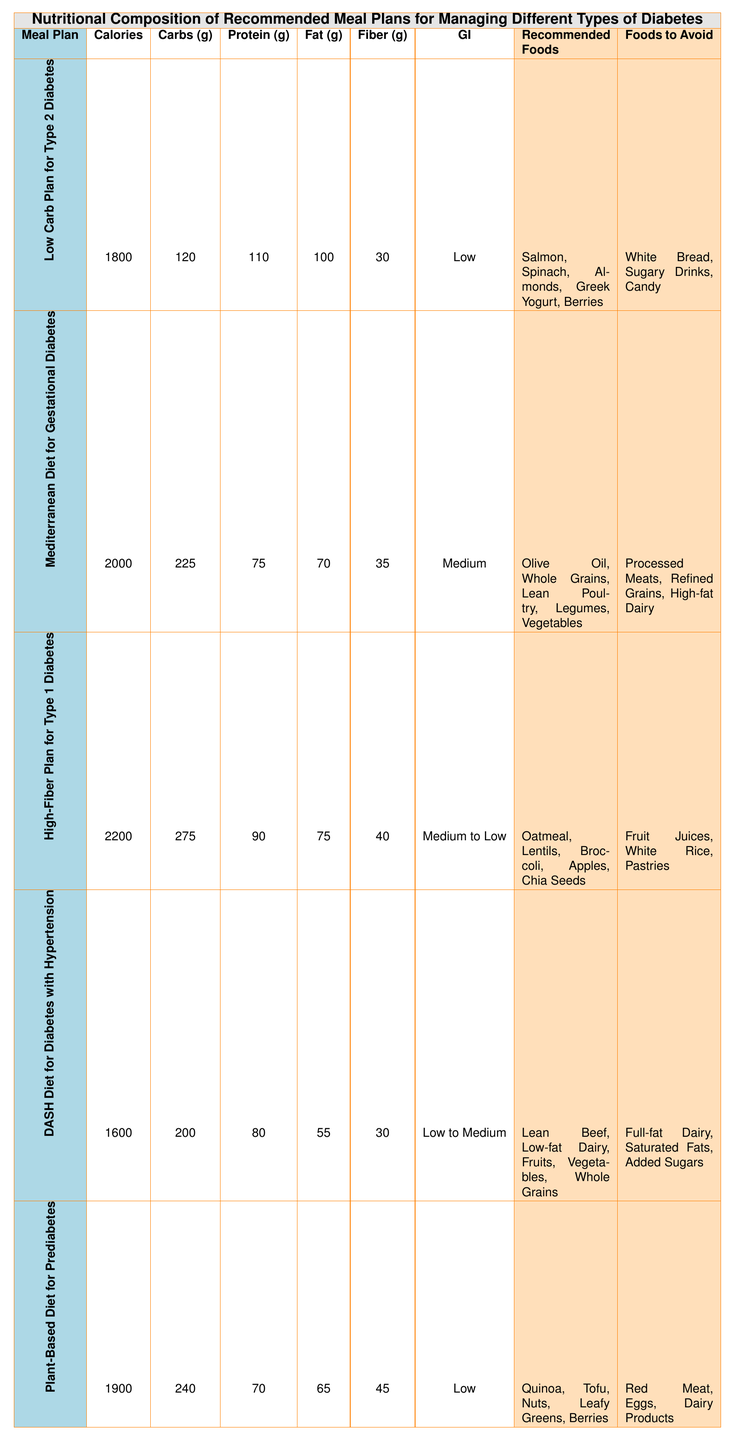What is the total calorie count of the "Plant-Based Diet for Prediabetes"? The "Plant-Based Diet for Prediabetes" plan has a calorie count listed directly in the table. The value is 1900 calories.
Answer: 1900 Which meal plan has the highest protein content? The "Low Carb Plan for Type 2 Diabetes" has 110 grams of protein, while the "High-Fiber Plan for Type 1 Diabetes" has 90 grams, and the "Mediterranean Diet for Gestational Diabetes" has 75 grams. Therefore, the "Low Carb Plan for Type 2 Diabetes" has the highest protein content.
Answer: Low Carb Plan for Type 2 Diabetes What is the difference in total calories between the "High-Fiber Plan for Type 1 Diabetes" and the "DASH Diet for Diabetes with Hypertension"? The total calories for the "High-Fiber Plan for Type 1 Diabetes" is 2200, and for the "DASH Diet for Diabetes with Hypertension" it is 1600. The difference is 2200 - 1600 = 600 calories.
Answer: 600 Do any meal plans have a low glycemic index? According to the table, the "Low Carb Plan for Type 2 Diabetes," "DASH Diet for Diabetes with Hypertension," and "Plant-Based Diet for Prediabetes" all have a low glycemic index. Therefore, there are meal plans with a low glycemic index.
Answer: Yes Which meal plan has the highest fiber content, and how much is it? The "Plant-Based Diet for Prediabetes" has 45 grams of fiber, which is higher than the other plans: "High-Fiber Plan for Type 1 Diabetes" has 40 grams, while all others have less. This indicates that the "Plant-Based Diet for Prediabetes" has the highest fiber content.
Answer: Plant-Based Diet for Prediabetes, 45 grams What is the total amount of carbohydrates in the "Mediterranean Diet for Gestational Diabetes"? The table shows that the "Mediterranean Diet for Gestational Diabetes" contains 225 grams of carbohydrates, as stated directly in the meal plan details.
Answer: 225 grams Which food items should be avoided in the "High-Fiber Plan for Type 1 Diabetes"? The table lists the foods to avoid for this meal plan, which are "Fruit Juices," "White Rice," and "Pastries." Therefore, these are the food items to avoid.
Answer: Fruit Juices, White Rice, Pastries Calculate the average calories of all the meal plans listed. Adding the total calories from all meal plans gives: 1800 + 2000 + 2200 + 1600 + 1900 = 11500. There are 5 meal plans, so the average is 11500 / 5 = 2300 calories.
Answer: 2300 Is the "Mediterranean Diet for Gestational Diabetes" the only plan with a medium glycemic index? The "Mediterranean Diet for Gestational Diabetes" is noted to have a medium glycemic index, but the "High-Fiber Plan for Type 1 Diabetes" is listed as medium to low. Thus, the "Mediterranean Diet for Gestational Diabetes" is not the only one; it is one of two.
Answer: No What can be inferred about the recommended foods in the "Low Carb Plan for Type 2 Diabetes"? The table indicates that this meal plan recommends foods such as "Salmon," "Spinach," "Almonds," "Greek Yogurt," and "Berries." These foods are generally low in carbohydrates and contribute healthy fats and proteins, promoting better blood sugar control for Type 2 Diabetes.
Answer: They are mostly low in carbs and high in healthy fats/proteins 